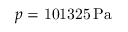Convert formula to latex. <formula><loc_0><loc_0><loc_500><loc_500>p = { 1 0 1 3 2 5 } { \, } { P a }</formula> 